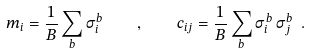Convert formula to latex. <formula><loc_0><loc_0><loc_500><loc_500>m _ { i } = \frac { 1 } { B } \sum _ { b } \sigma _ { i } ^ { b } \quad , \quad c _ { i j } = \frac { 1 } { B } \sum _ { b } \sigma _ { i } ^ { b } \, \sigma _ { j } ^ { b } \ .</formula> 